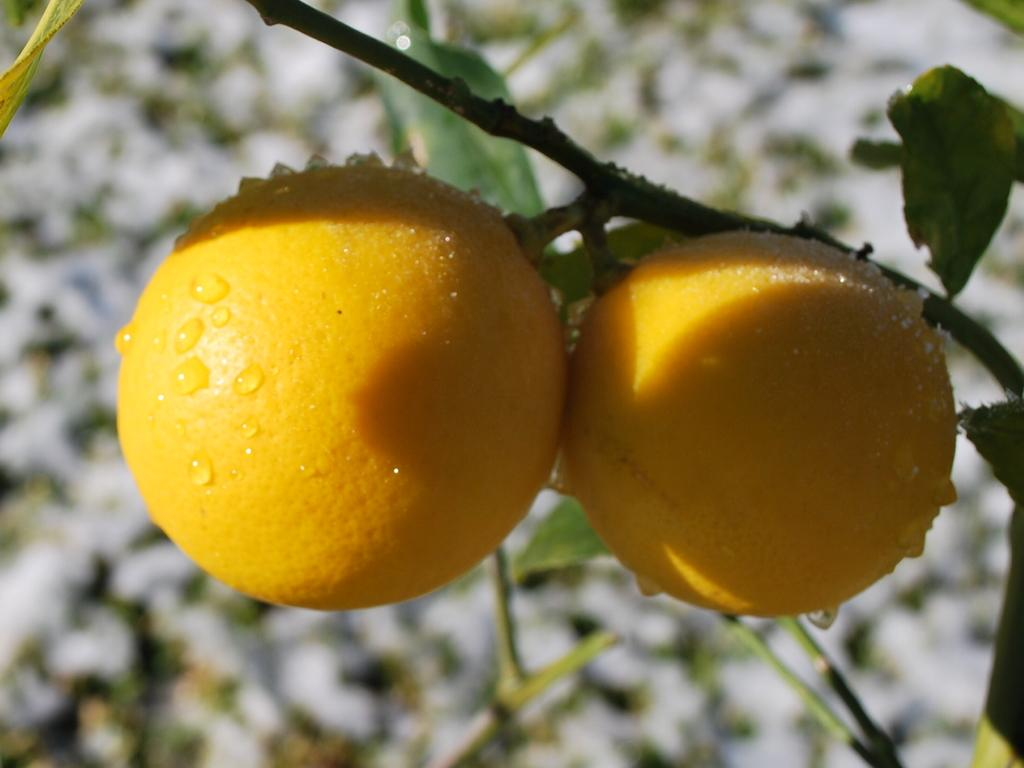What type of fruit can be seen on the plant in the image? There are lemons on a plant in the image. Can you describe the plant that the lemons are growing on? Unfortunately, the image only shows the lemons and not the plant itself. What type of leather is being used to make the governor's chair in the image? There is no governor or chair present in the image; it only shows lemons on a plant. 